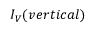Convert formula to latex. <formula><loc_0><loc_0><loc_500><loc_500>I _ { V } ( v e r t i c a l )</formula> 